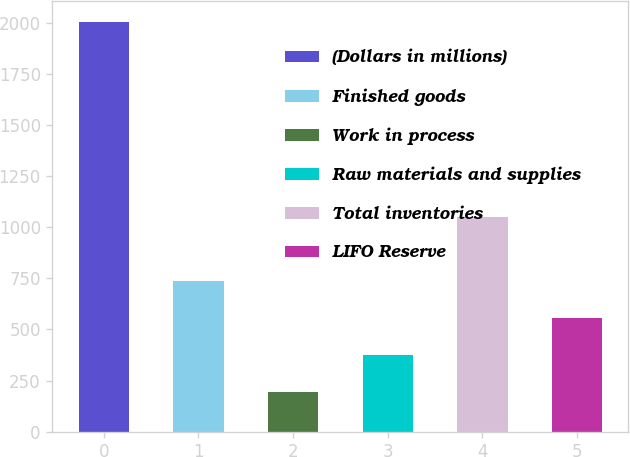Convert chart to OTSL. <chart><loc_0><loc_0><loc_500><loc_500><bar_chart><fcel>(Dollars in millions)<fcel>Finished goods<fcel>Work in process<fcel>Raw materials and supplies<fcel>Total inventories<fcel>LIFO Reserve<nl><fcel>2007<fcel>738.6<fcel>195<fcel>376.2<fcel>1049<fcel>557.4<nl></chart> 